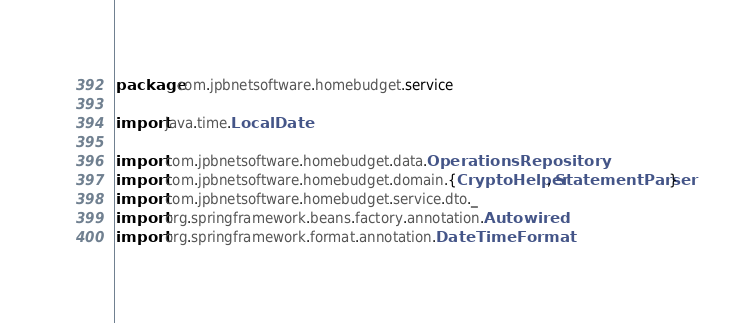Convert code to text. <code><loc_0><loc_0><loc_500><loc_500><_Scala_>package com.jpbnetsoftware.homebudget.service

import java.time.LocalDate

import com.jpbnetsoftware.homebudget.data.OperationsRepository
import com.jpbnetsoftware.homebudget.domain.{CryptoHelper, StatementParser}
import com.jpbnetsoftware.homebudget.service.dto._
import org.springframework.beans.factory.annotation.Autowired
import org.springframework.format.annotation.DateTimeFormat</code> 